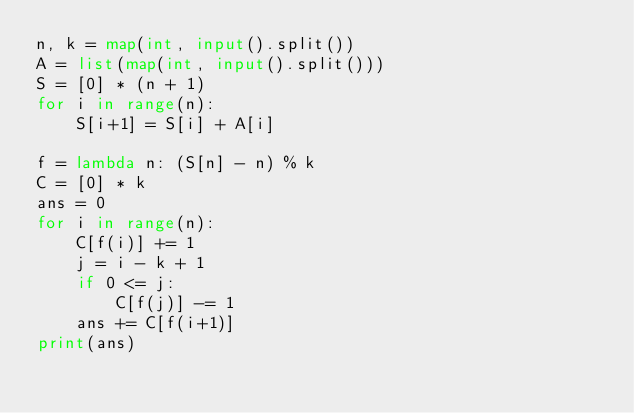<code> <loc_0><loc_0><loc_500><loc_500><_Python_>n, k = map(int, input().split())
A = list(map(int, input().split()))
S = [0] * (n + 1)
for i in range(n):
    S[i+1] = S[i] + A[i]

f = lambda n: (S[n] - n) % k
C = [0] * k
ans = 0
for i in range(n):
    C[f(i)] += 1
    j = i - k + 1
    if 0 <= j:
        C[f(j)] -= 1
    ans += C[f(i+1)]
print(ans)</code> 